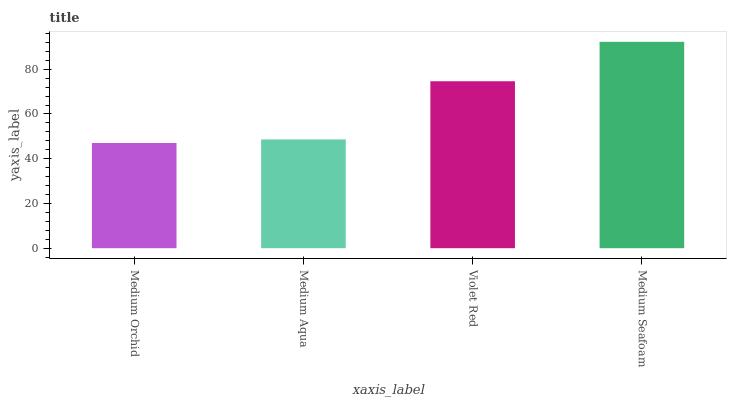Is Medium Orchid the minimum?
Answer yes or no. Yes. Is Medium Seafoam the maximum?
Answer yes or no. Yes. Is Medium Aqua the minimum?
Answer yes or no. No. Is Medium Aqua the maximum?
Answer yes or no. No. Is Medium Aqua greater than Medium Orchid?
Answer yes or no. Yes. Is Medium Orchid less than Medium Aqua?
Answer yes or no. Yes. Is Medium Orchid greater than Medium Aqua?
Answer yes or no. No. Is Medium Aqua less than Medium Orchid?
Answer yes or no. No. Is Violet Red the high median?
Answer yes or no. Yes. Is Medium Aqua the low median?
Answer yes or no. Yes. Is Medium Aqua the high median?
Answer yes or no. No. Is Violet Red the low median?
Answer yes or no. No. 